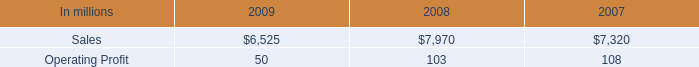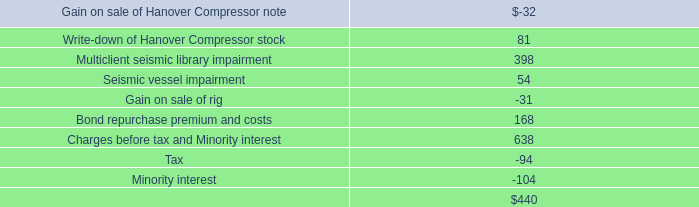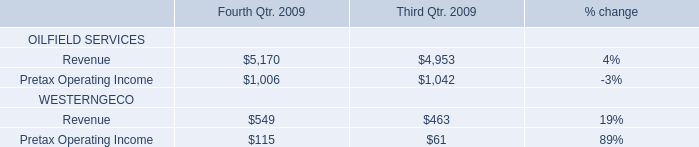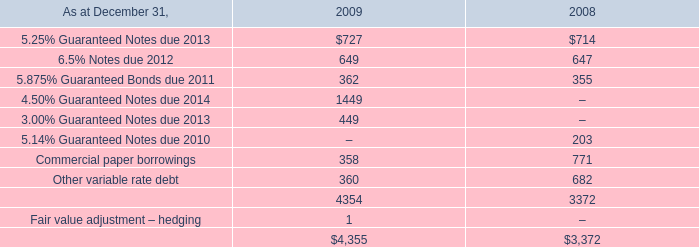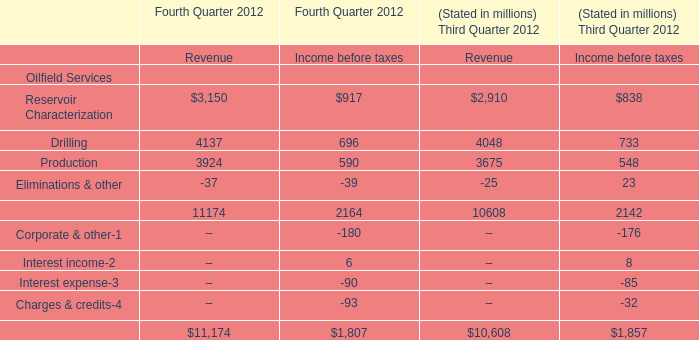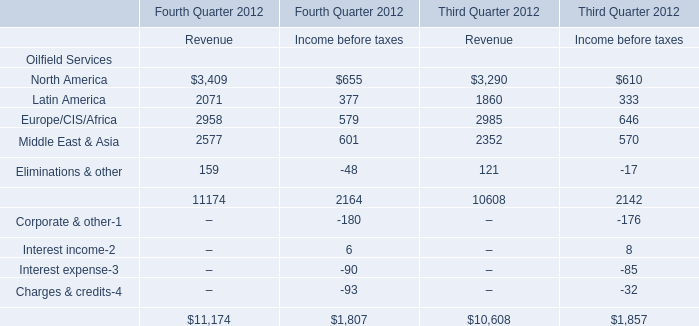what was the percentage increase in annual sales of printing papers and graphic arts supplies and equipment from 2007 to 2008? 
Computations: ((5.2 - 4.7) / 4.7)
Answer: 0.10638. 